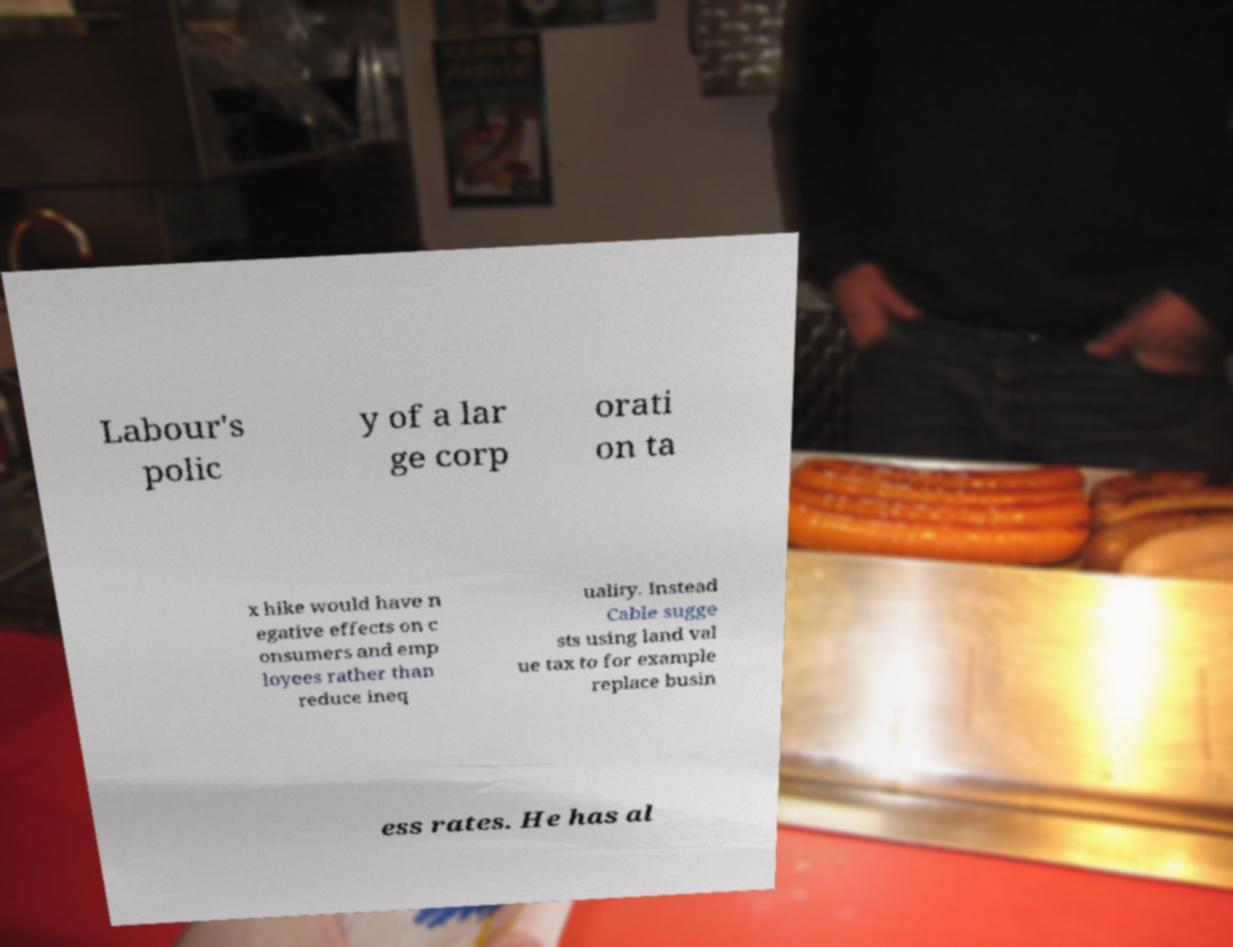I need the written content from this picture converted into text. Can you do that? Labour's polic y of a lar ge corp orati on ta x hike would have n egative effects on c onsumers and emp loyees rather than reduce ineq uality. Instead Cable sugge sts using land val ue tax to for example replace busin ess rates. He has al 